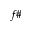Convert formula to latex. <formula><loc_0><loc_0><loc_500><loc_500>f \#</formula> 